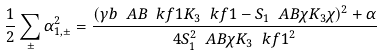<formula> <loc_0><loc_0><loc_500><loc_500>\frac { 1 } { 2 } \sum _ { \pm } \alpha _ { 1 , \pm } ^ { 2 } = \frac { ( \gamma b \ A B { \ k f 1 } { K _ { 3 } } { \ k f 1 } - S _ { 1 } \ A B { \chi } { K _ { 3 } } { \chi } ) ^ { 2 } + \alpha } { 4 S _ { 1 } ^ { 2 } \ A B { \chi } { K _ { 3 } } { \ k f 1 } ^ { 2 } }</formula> 